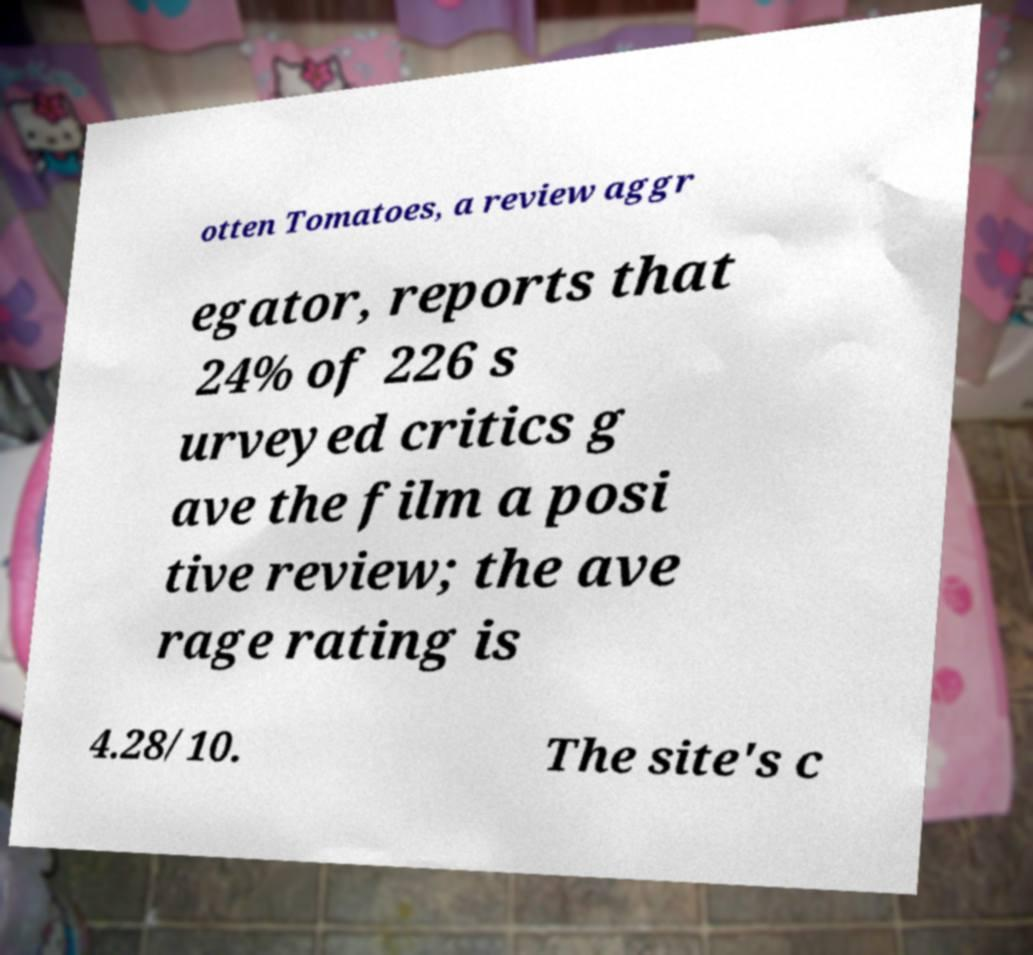Could you assist in decoding the text presented in this image and type it out clearly? otten Tomatoes, a review aggr egator, reports that 24% of 226 s urveyed critics g ave the film a posi tive review; the ave rage rating is 4.28/10. The site's c 